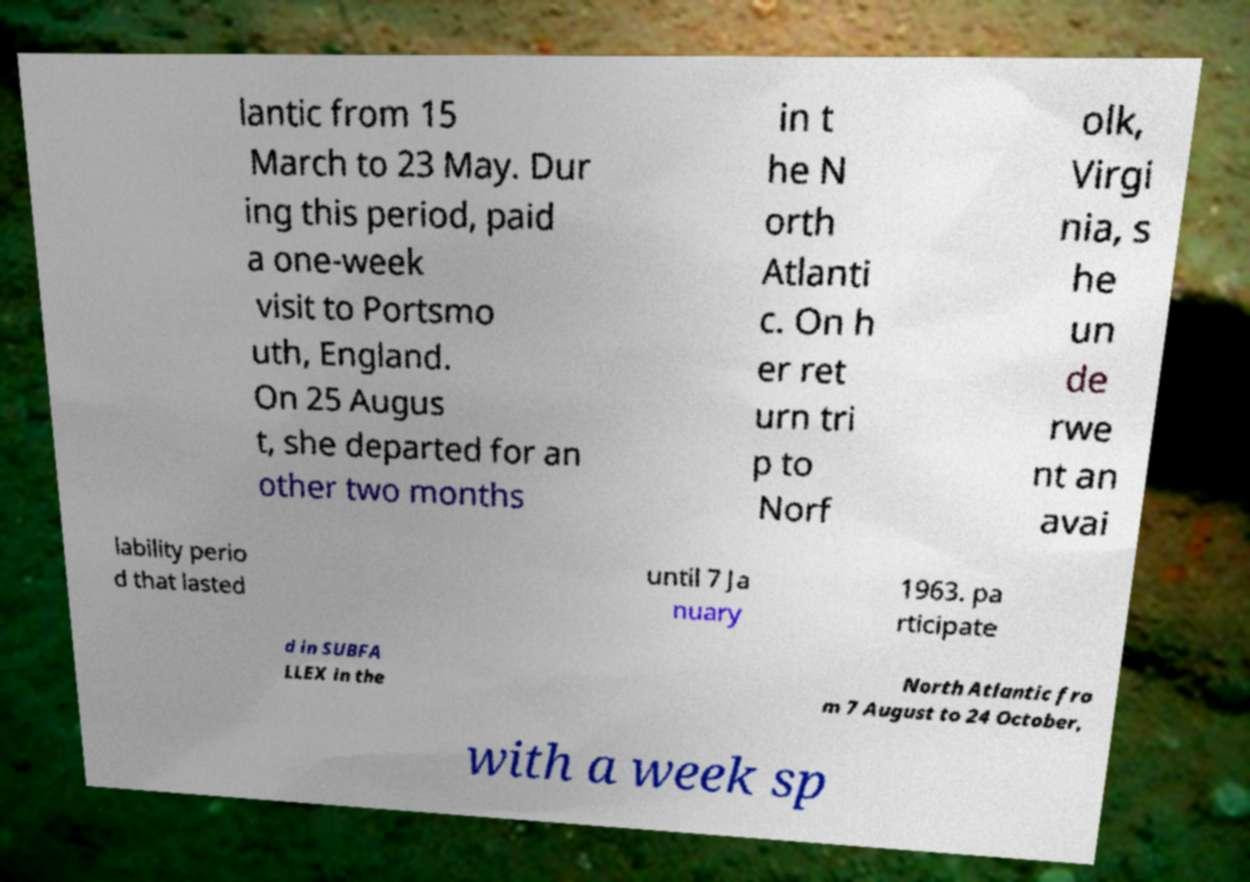Please identify and transcribe the text found in this image. lantic from 15 March to 23 May. Dur ing this period, paid a one-week visit to Portsmo uth, England. On 25 Augus t, she departed for an other two months in t he N orth Atlanti c. On h er ret urn tri p to Norf olk, Virgi nia, s he un de rwe nt an avai lability perio d that lasted until 7 Ja nuary 1963. pa rticipate d in SUBFA LLEX in the North Atlantic fro m 7 August to 24 October, with a week sp 